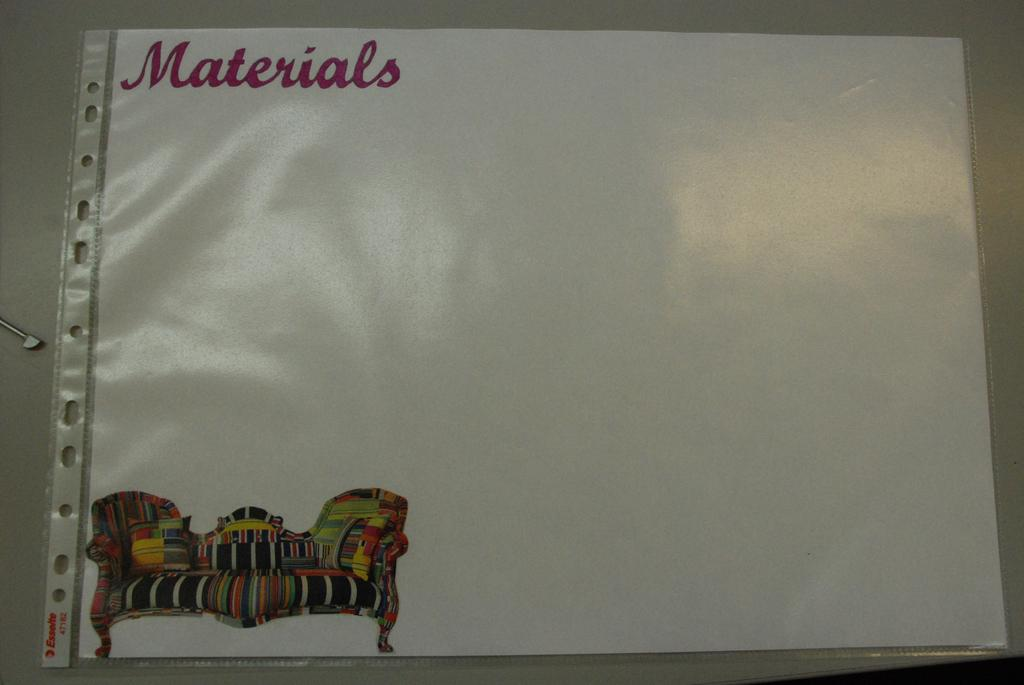<image>
Present a compact description of the photo's key features. A piece of papaer with a picture of a couch that says materials. 